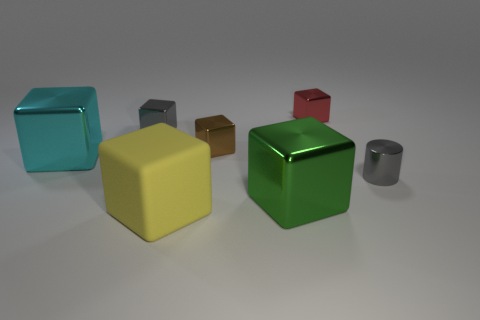Subtract 2 blocks. How many blocks are left? 4 Subtract all tiny red blocks. How many blocks are left? 5 Subtract all red cubes. How many cubes are left? 5 Subtract all blue cubes. Subtract all cyan cylinders. How many cubes are left? 6 Add 1 tiny gray cubes. How many objects exist? 8 Subtract all cylinders. How many objects are left? 6 Add 5 yellow rubber cubes. How many yellow rubber cubes exist? 6 Subtract 0 cyan spheres. How many objects are left? 7 Subtract all small gray cubes. Subtract all yellow objects. How many objects are left? 5 Add 3 green metallic things. How many green metallic things are left? 4 